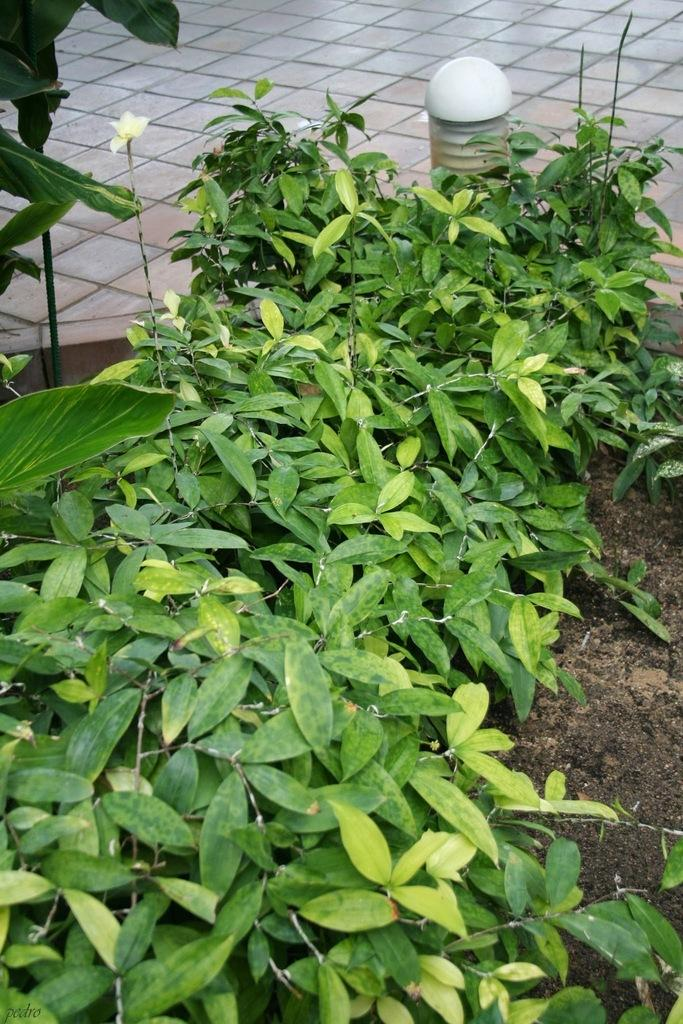What is located in the foreground of the image? There are plants in the foreground of the image. What is positioned behind the plants? There is a lamp behind the plants. Can you describe the floor in the image? The floor is not visible at the top of the image, as this statement seems to be a transcription error. What type of sugar is being used to sweeten the letter in the image? There is no sugar or letter present in the image. What color is the underwear worn by the plants in the image? There are no underwear or plants wearing underwear in the image. 